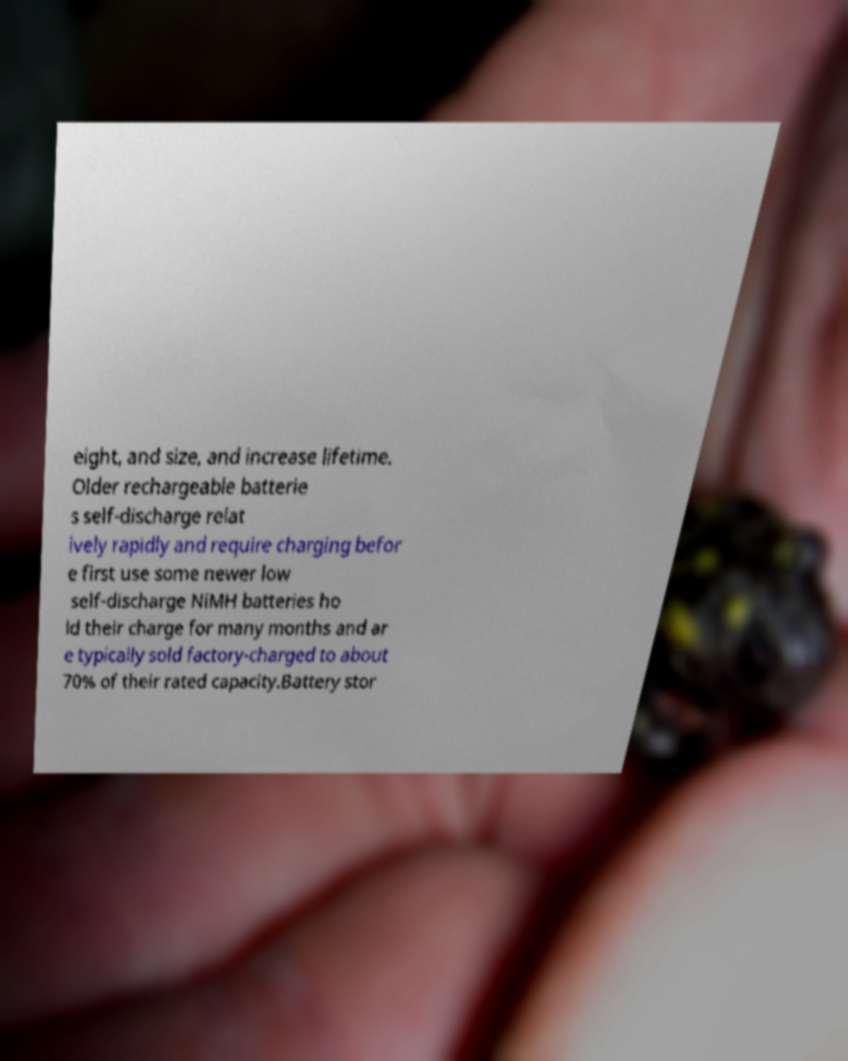Can you read and provide the text displayed in the image?This photo seems to have some interesting text. Can you extract and type it out for me? eight, and size, and increase lifetime. Older rechargeable batterie s self-discharge relat ively rapidly and require charging befor e first use some newer low self-discharge NiMH batteries ho ld their charge for many months and ar e typically sold factory-charged to about 70% of their rated capacity.Battery stor 